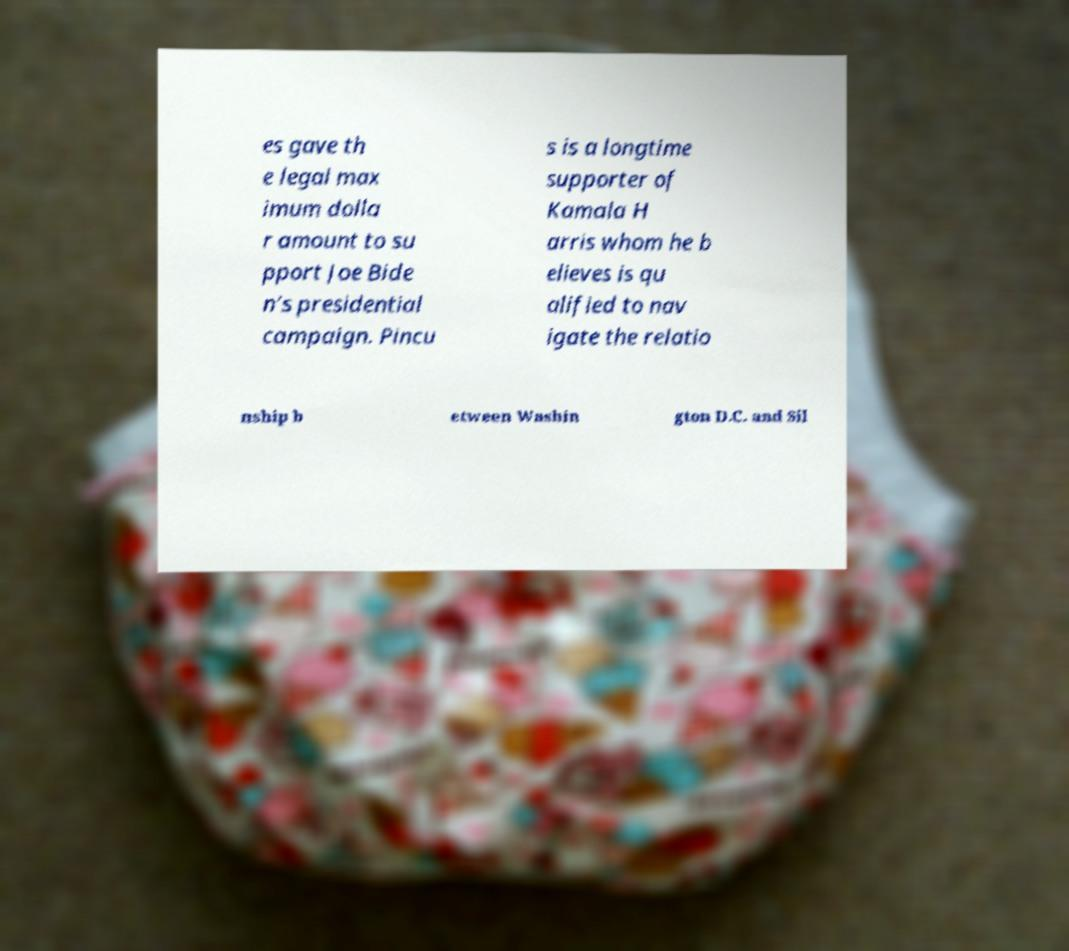Can you read and provide the text displayed in the image?This photo seems to have some interesting text. Can you extract and type it out for me? es gave th e legal max imum dolla r amount to su pport Joe Bide n’s presidential campaign. Pincu s is a longtime supporter of Kamala H arris whom he b elieves is qu alified to nav igate the relatio nship b etween Washin gton D.C. and Sil 